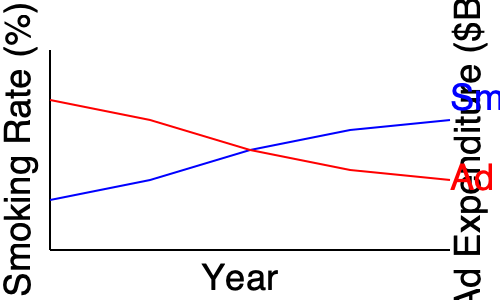Based on the graph showing tobacco advertising expenditure and smoking rates over time, what legal argument could be made regarding the tobacco industry's claim that advertising does not increase smoking rates? To answer this question, we need to analyze the trends shown in the graph and consider their legal implications:

1. Smoking rate trend: The blue line shows a steady decline in smoking rates over time.

2. Advertising expenditure trend: The red line indicates an increase in tobacco advertising expenditure over the same period.

3. Inverse relationship: As advertising spending increases, smoking rates decrease, which seems counterintuitive if advertising were effective in promoting smoking.

4. Industry claim: Tobacco companies often argue that their advertising does not increase smoking rates but only affects brand choice among existing smokers.

5. Legal argument: As a public interest lawyer, you could argue that:
   a) The inverse relationship between advertising spending and smoking rates does not disprove the harmful effects of advertising.
   b) The decline in smoking rates might have been even steeper without the increased advertising expenditure.
   c) The industry's continued high spending on advertising, despite declining smoking rates, suggests they believe it has some effect on maintaining or slowing the decline of their customer base.

6. Causation vs. correlation: Emphasize that the graph shows correlation, not causation. Other factors (e.g., public health campaigns, smoking bans) likely contributed to the smoking rate decline.

7. Public policy implication: Argue that if advertising truly had no impact on smoking rates, regulations restricting tobacco advertising would not harm the industry and could be implemented without legal challenge.
Answer: The inverse relationship between rising ad expenditure and declining smoking rates does not prove advertising's ineffectiveness; it may have slowed the decline, and the industry's continued high spending suggests they believe in its impact. 